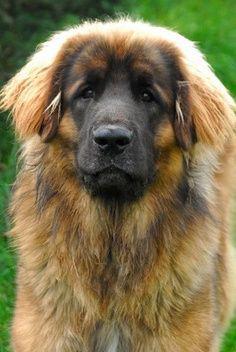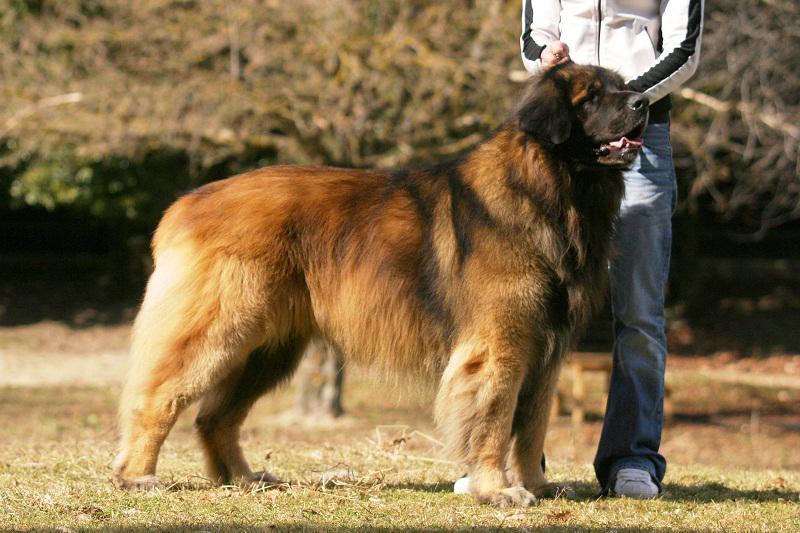The first image is the image on the left, the second image is the image on the right. Given the left and right images, does the statement "At least one of the dogs in an image is not alone." hold true? Answer yes or no. Yes. 